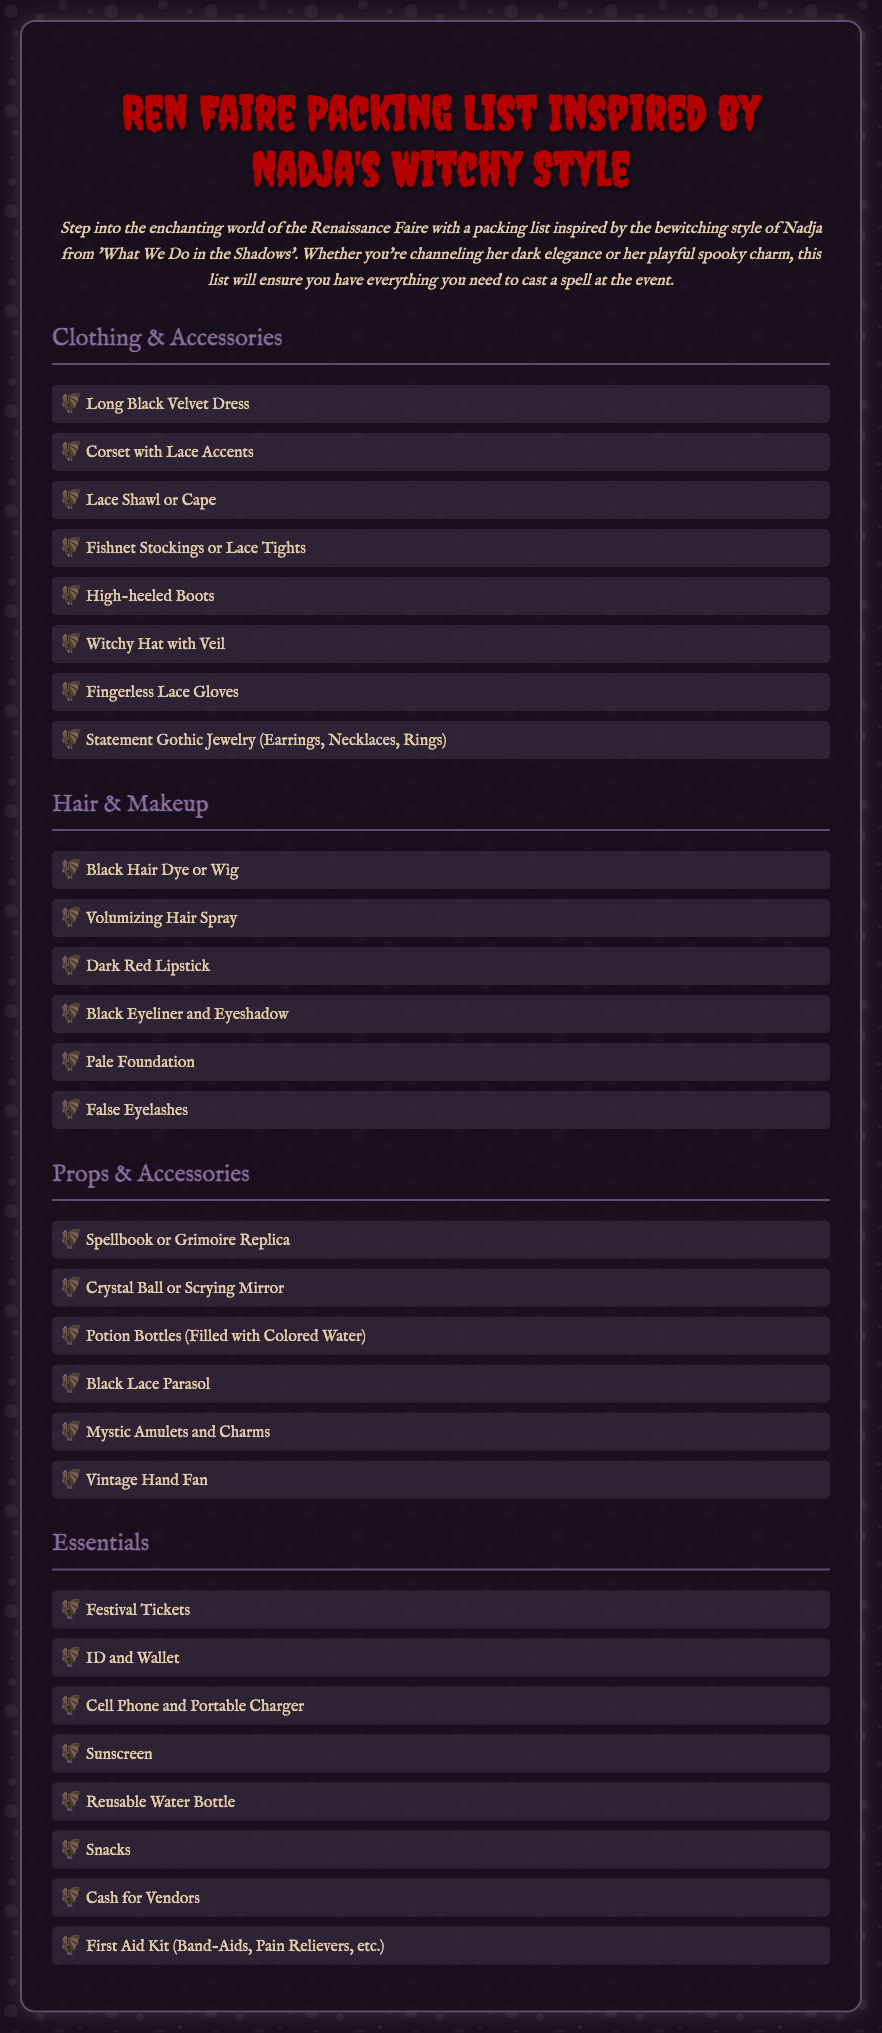what is the title of the document? The title of the document is prominently displayed at the top, indicating the main theme of the packing list.
Answer: Ren Faire Packing List Inspired by Nadja's Witchy Style how many sections are in the packing list? The packing list is divided into four main sections, each detailing different types of items to pack.
Answer: 4 what is one item listed under Clothing & Accessories? The document provides a variety of items specific to the clothing category.
Answer: Long Black Velvet Dress which makeup item is included in the Hair & Makeup section? This section provides items for beauty, specifically those that fit Nadja's style.
Answer: Dark Red Lipstick what type of prop is mentioned as a replica in the Props & Accessories section? The list includes various props that align with the theme and style described.
Answer: Spellbook or Grimoire Replica what is one of the essentials for the festival mentioned? The 'Essentials' section lists crucial items needed for attending the event.
Answer: Festival Tickets 